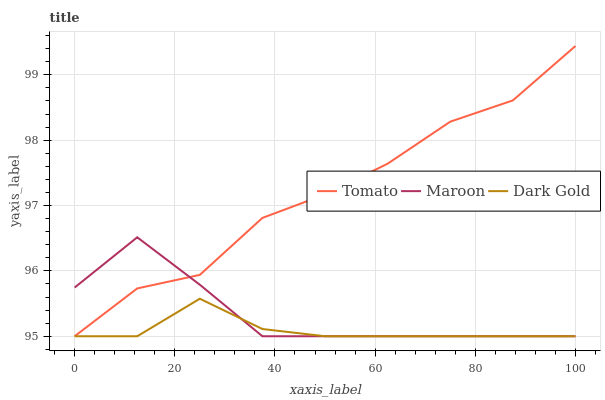Does Dark Gold have the minimum area under the curve?
Answer yes or no. Yes. Does Tomato have the maximum area under the curve?
Answer yes or no. Yes. Does Maroon have the minimum area under the curve?
Answer yes or no. No. Does Maroon have the maximum area under the curve?
Answer yes or no. No. Is Dark Gold the smoothest?
Answer yes or no. Yes. Is Tomato the roughest?
Answer yes or no. Yes. Is Maroon the smoothest?
Answer yes or no. No. Is Maroon the roughest?
Answer yes or no. No. Does Tomato have the lowest value?
Answer yes or no. Yes. Does Tomato have the highest value?
Answer yes or no. Yes. Does Maroon have the highest value?
Answer yes or no. No. Does Maroon intersect Dark Gold?
Answer yes or no. Yes. Is Maroon less than Dark Gold?
Answer yes or no. No. Is Maroon greater than Dark Gold?
Answer yes or no. No. 